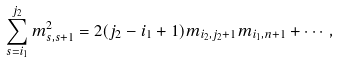Convert formula to latex. <formula><loc_0><loc_0><loc_500><loc_500>\sum _ { s = i _ { 1 } } ^ { j _ { 2 } } m ^ { 2 } _ { s , s + 1 } = 2 ( j _ { 2 } - i _ { 1 } + 1 ) m _ { i _ { 2 } , j _ { 2 } + 1 } m _ { i _ { 1 } , n + 1 } + \cdots ,</formula> 